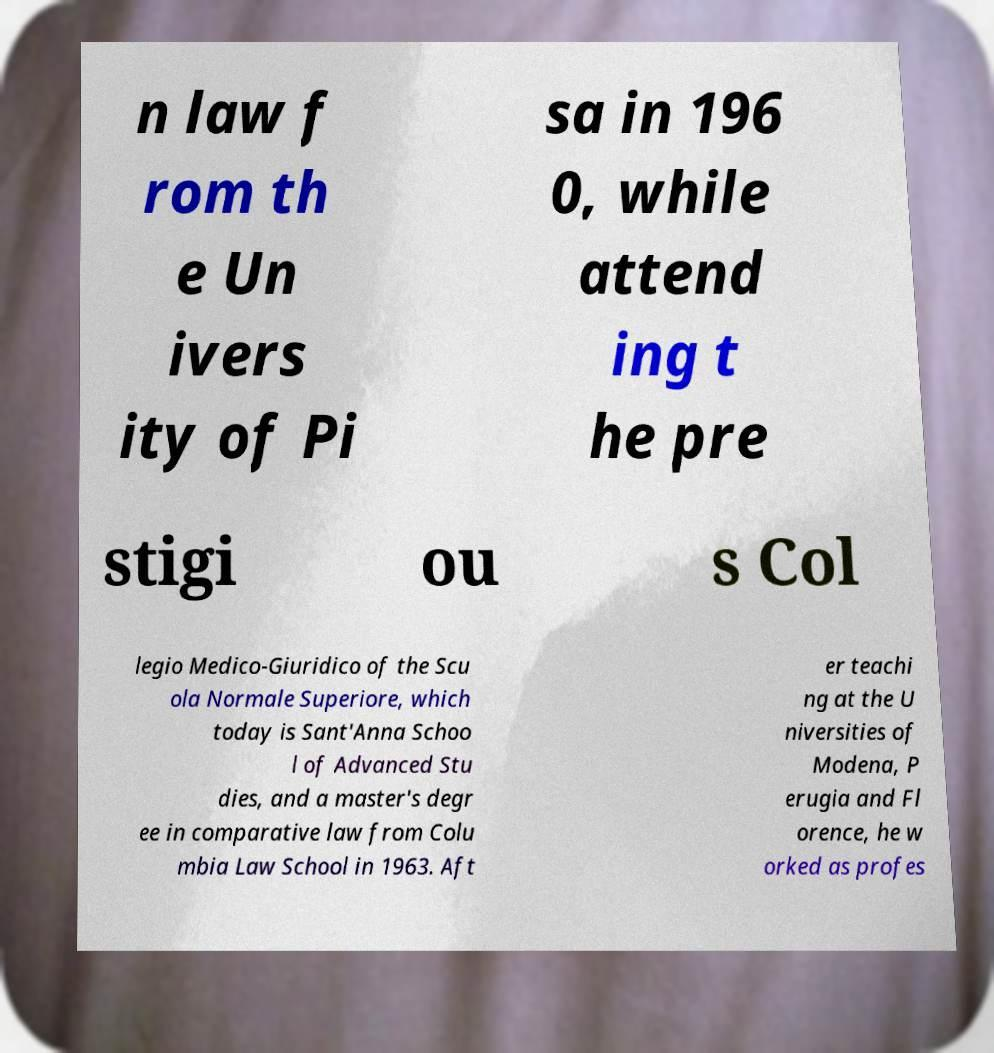Could you extract and type out the text from this image? n law f rom th e Un ivers ity of Pi sa in 196 0, while attend ing t he pre stigi ou s Col legio Medico-Giuridico of the Scu ola Normale Superiore, which today is Sant'Anna Schoo l of Advanced Stu dies, and a master's degr ee in comparative law from Colu mbia Law School in 1963. Aft er teachi ng at the U niversities of Modena, P erugia and Fl orence, he w orked as profes 